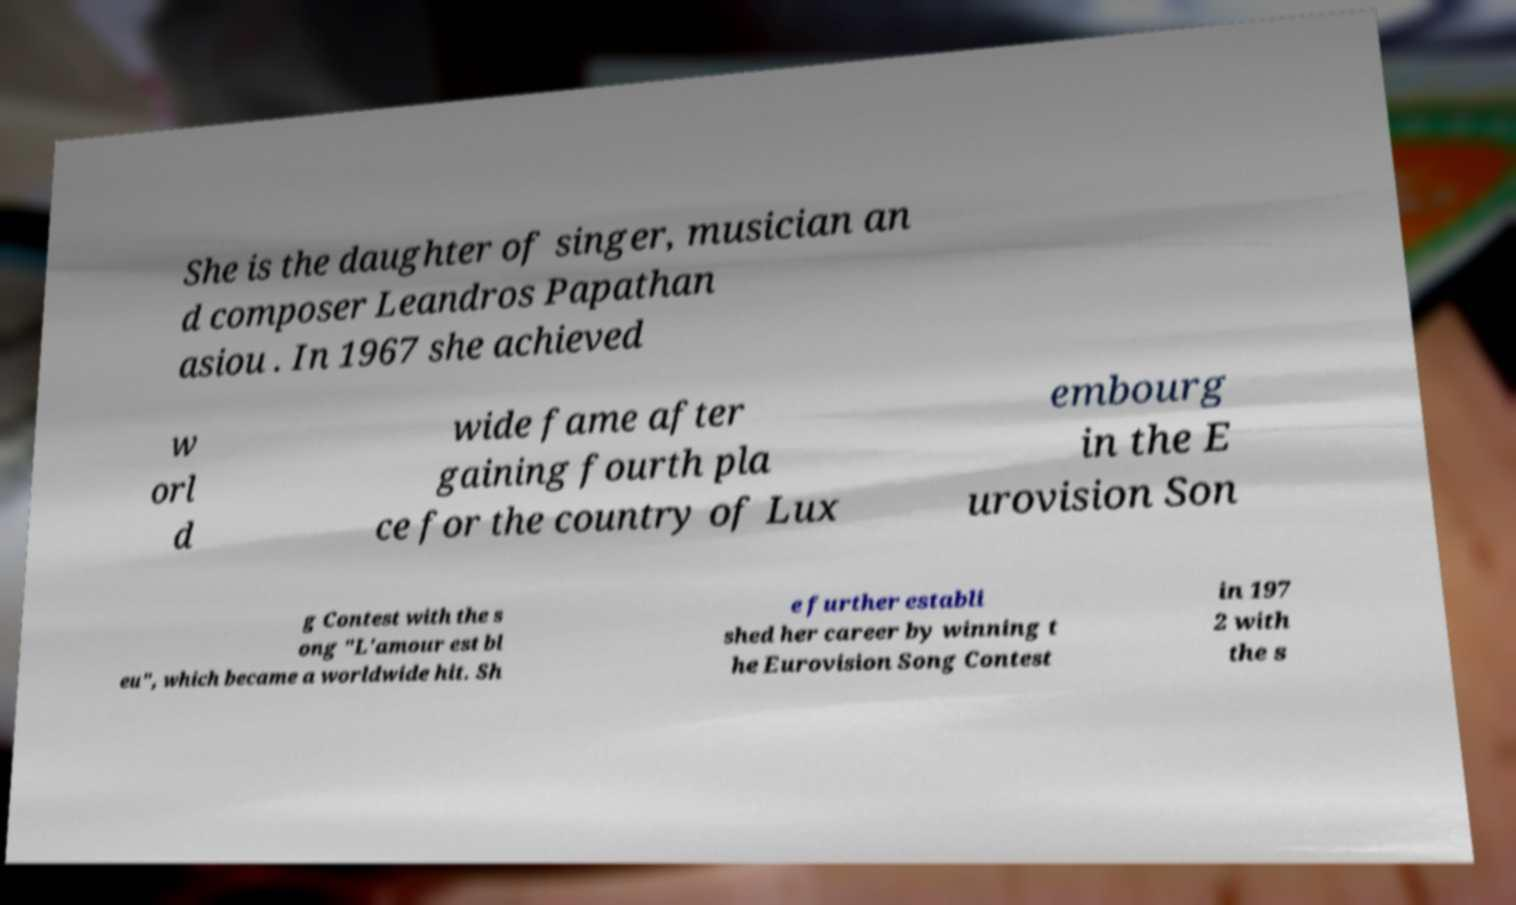Please read and relay the text visible in this image. What does it say? She is the daughter of singer, musician an d composer Leandros Papathan asiou . In 1967 she achieved w orl d wide fame after gaining fourth pla ce for the country of Lux embourg in the E urovision Son g Contest with the s ong "L'amour est bl eu", which became a worldwide hit. Sh e further establi shed her career by winning t he Eurovision Song Contest in 197 2 with the s 